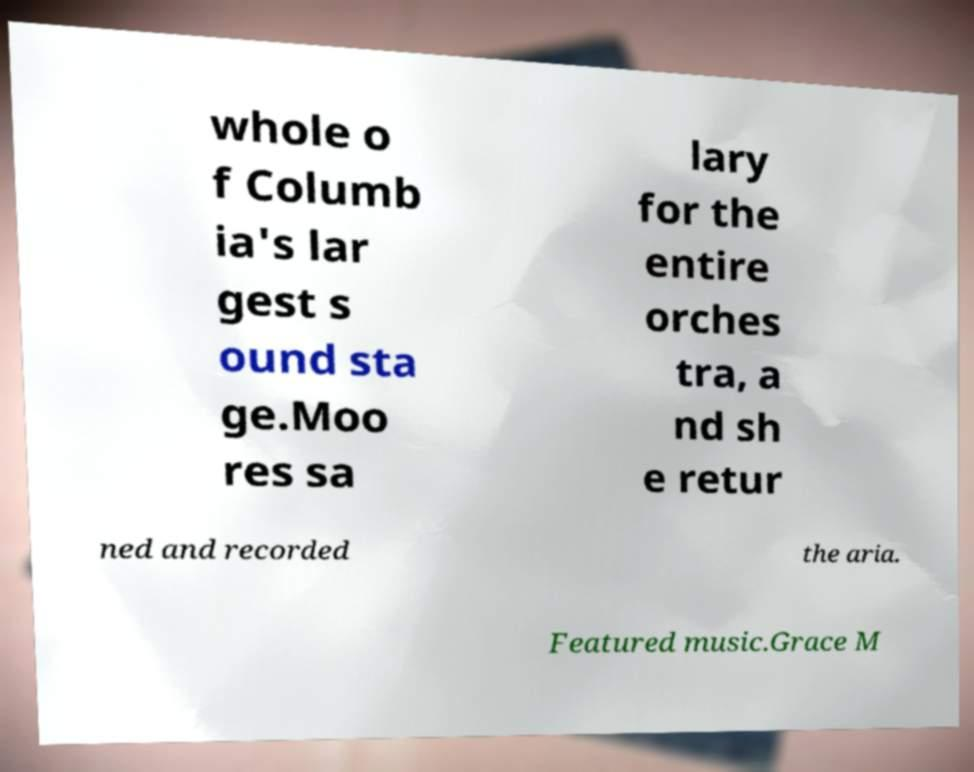Could you extract and type out the text from this image? whole o f Columb ia's lar gest s ound sta ge.Moo res sa lary for the entire orches tra, a nd sh e retur ned and recorded the aria. Featured music.Grace M 